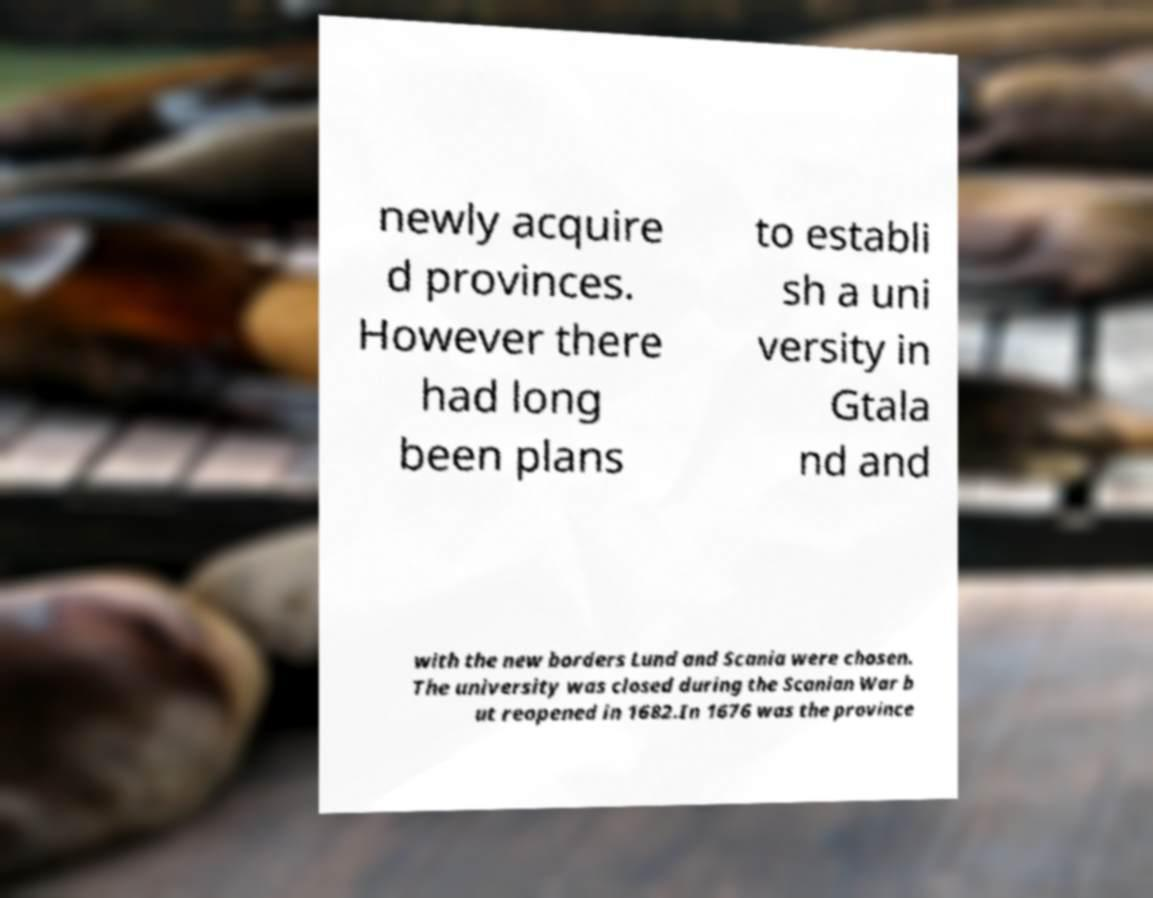Could you assist in decoding the text presented in this image and type it out clearly? newly acquire d provinces. However there had long been plans to establi sh a uni versity in Gtala nd and with the new borders Lund and Scania were chosen. The university was closed during the Scanian War b ut reopened in 1682.In 1676 was the province 